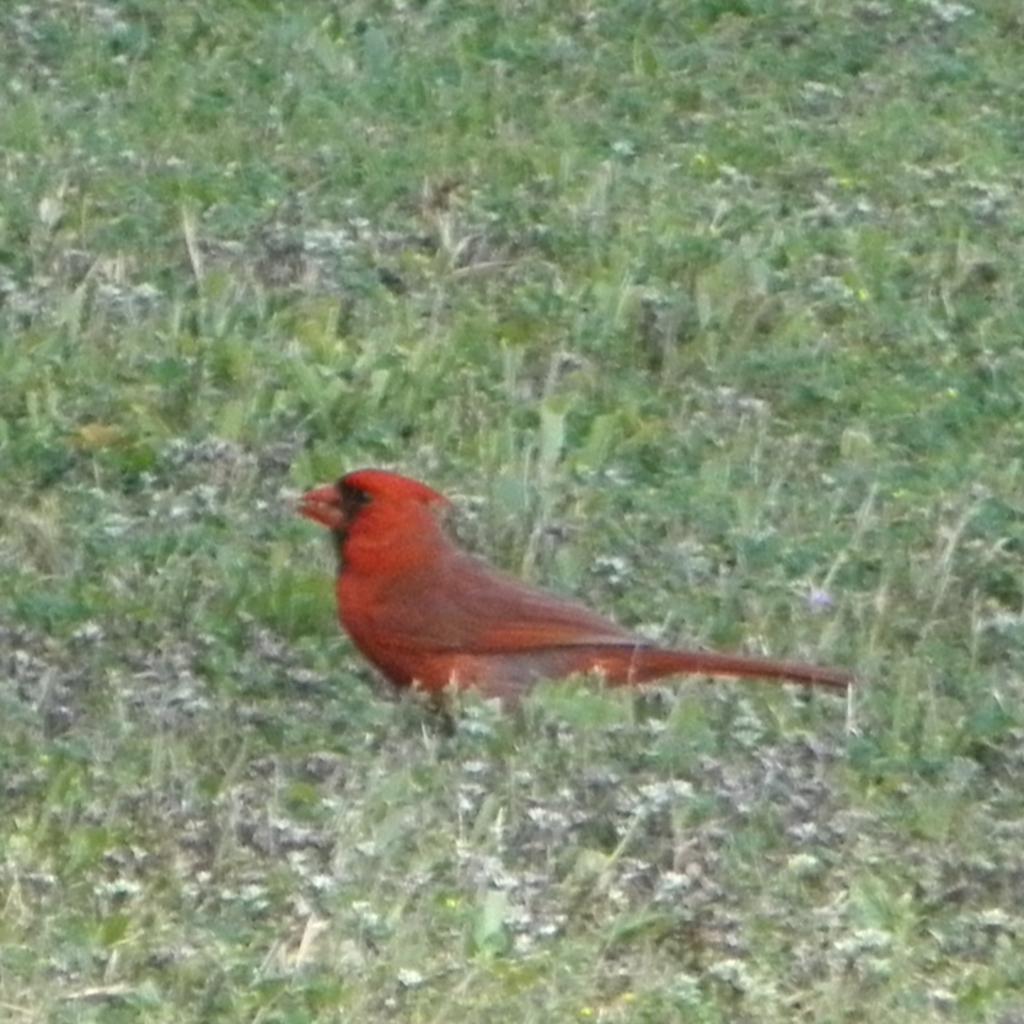Please provide a concise description of this image. In this image I can see a bird is in orange color in this grass. 